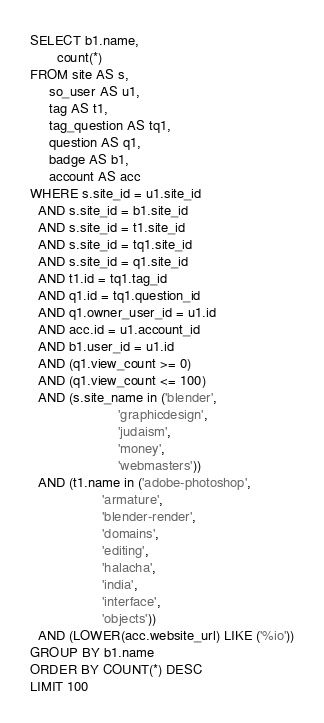<code> <loc_0><loc_0><loc_500><loc_500><_SQL_>SELECT b1.name,
       count(*)
FROM site AS s,
     so_user AS u1,
     tag AS t1,
     tag_question AS tq1,
     question AS q1,
     badge AS b1,
     account AS acc
WHERE s.site_id = u1.site_id
  AND s.site_id = b1.site_id
  AND s.site_id = t1.site_id
  AND s.site_id = tq1.site_id
  AND s.site_id = q1.site_id
  AND t1.id = tq1.tag_id
  AND q1.id = tq1.question_id
  AND q1.owner_user_id = u1.id
  AND acc.id = u1.account_id
  AND b1.user_id = u1.id
  AND (q1.view_count >= 0)
  AND (q1.view_count <= 100)
  AND (s.site_name in ('blender',
                       'graphicdesign',
                       'judaism',
                       'money',
                       'webmasters'))
  AND (t1.name in ('adobe-photoshop',
                   'armature',
                   'blender-render',
                   'domains',
                   'editing',
                   'halacha',
                   'india',
                   'interface',
                   'objects'))
  AND (LOWER(acc.website_url) LIKE ('%io'))
GROUP BY b1.name
ORDER BY COUNT(*) DESC
LIMIT 100</code> 